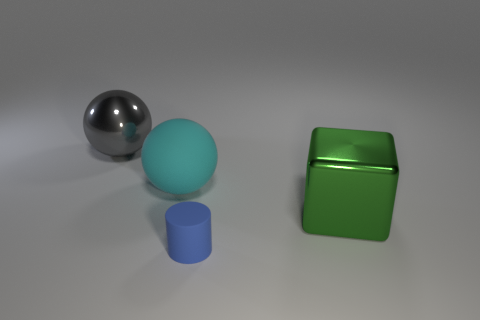Subtract all blocks. How many objects are left? 3 Subtract all cyan balls. How many balls are left? 1 Subtract 0 yellow spheres. How many objects are left? 4 Subtract 1 blocks. How many blocks are left? 0 Subtract all yellow balls. Subtract all cyan cubes. How many balls are left? 2 Subtract all red spheres. How many red blocks are left? 0 Subtract all tiny gray things. Subtract all large cyan balls. How many objects are left? 3 Add 2 big objects. How many big objects are left? 5 Add 3 blue cubes. How many blue cubes exist? 3 Add 4 tiny purple things. How many objects exist? 8 